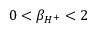<formula> <loc_0><loc_0><loc_500><loc_500>0 < \beta _ { H ^ { + } } < 2</formula> 